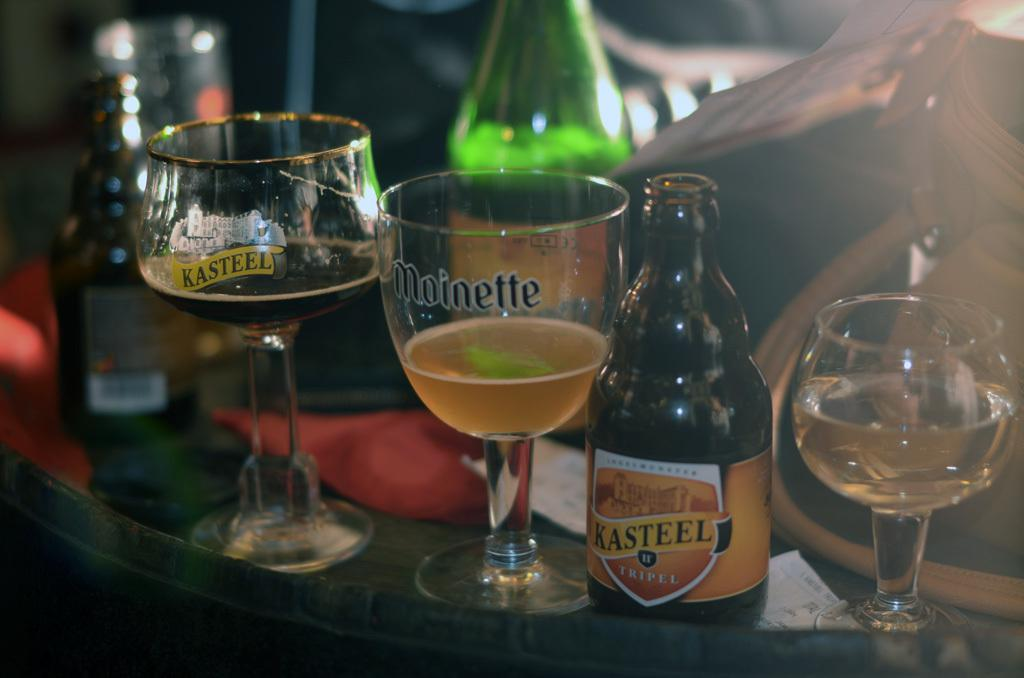What type of objects are present in the image? There is a group of wine glasses and two wine bottles in the image. Where are these objects located? The wine glasses and wine bottles are on a table. What type of creature can be seen interacting with the wine glasses in the image? There is no creature present in the image; it only features wine glasses and wine bottles on a table. 